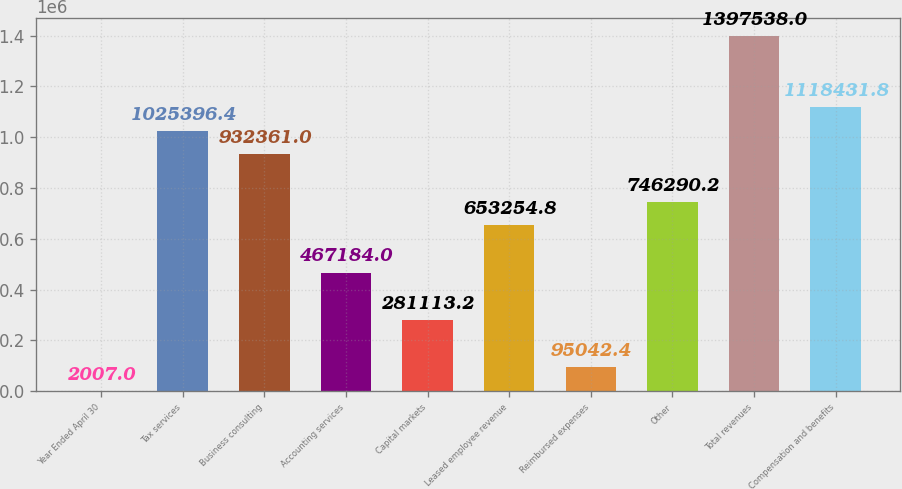Convert chart. <chart><loc_0><loc_0><loc_500><loc_500><bar_chart><fcel>Year Ended April 30<fcel>Tax services<fcel>Business consulting<fcel>Accounting services<fcel>Capital markets<fcel>Leased employee revenue<fcel>Reimbursed expenses<fcel>Other<fcel>Total revenues<fcel>Compensation and benefits<nl><fcel>2007<fcel>1.0254e+06<fcel>932361<fcel>467184<fcel>281113<fcel>653255<fcel>95042.4<fcel>746290<fcel>1.39754e+06<fcel>1.11843e+06<nl></chart> 